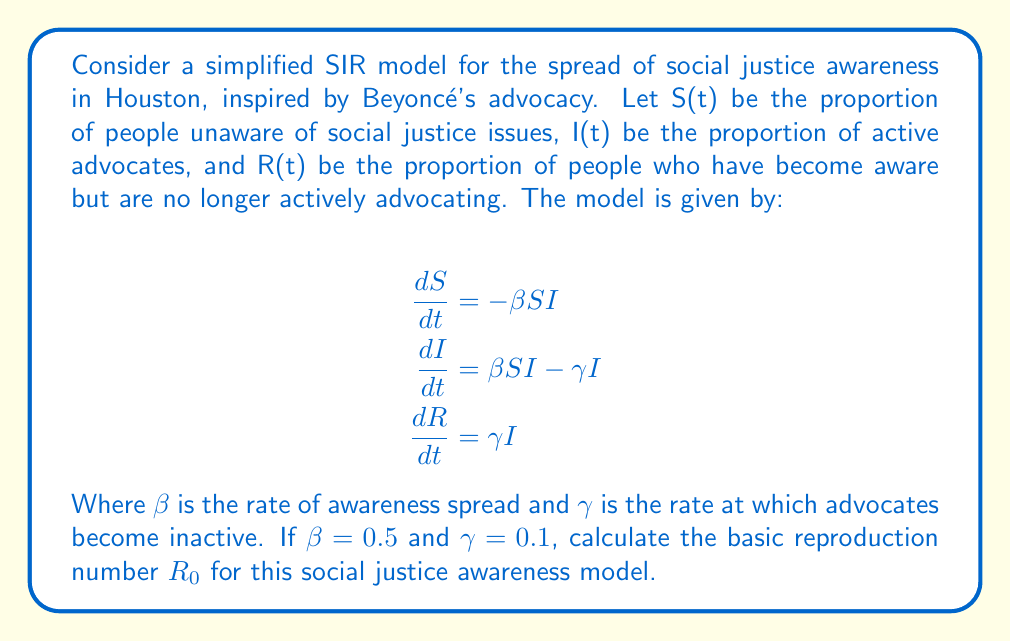Give your solution to this math problem. To solve this problem, we'll follow these steps:

1) In epidemiological models, the basic reproduction number $R_0$ represents the average number of new cases caused by one infected individual in a completely susceptible population.

2) For the SIR model, $R_0$ is given by the formula:

   $$R_0 = \frac{\beta}{\gamma}$$

3) In this case, we're given:
   $\beta = 0.5$ (rate of awareness spread)
   $\gamma = 0.1$ (rate at which advocates become inactive)

4) Substituting these values into the formula:

   $$R_0 = \frac{0.5}{0.1}$$

5) Simplifying:

   $$R_0 = 5$$

This means that, on average, one active social justice advocate will inspire five new advocates before becoming inactive, in a population entirely unaware of social justice issues.
Answer: $R_0 = 5$ 